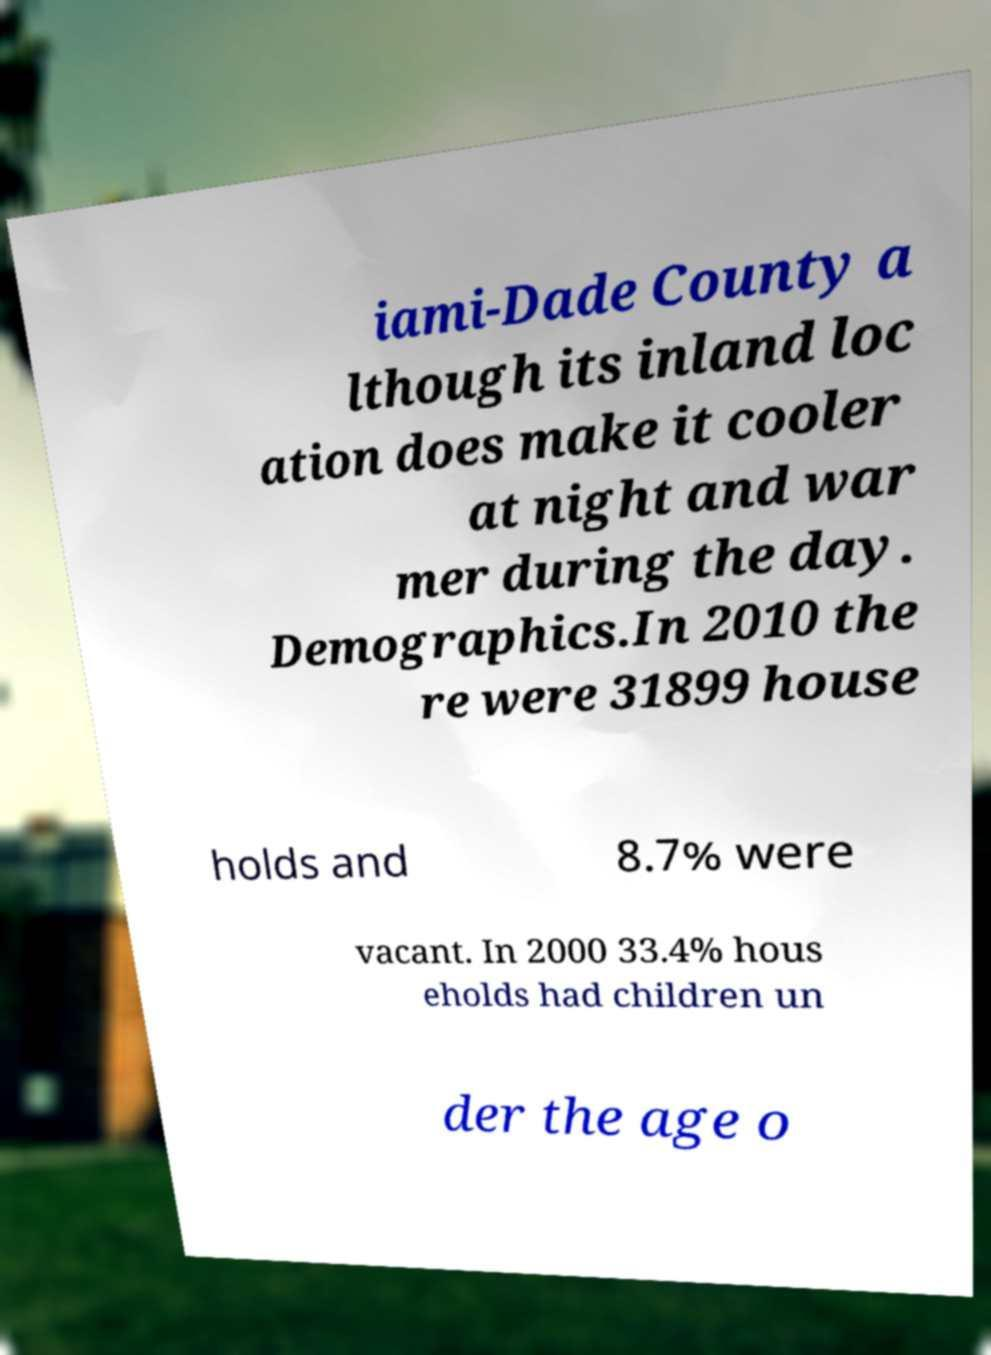Please read and relay the text visible in this image. What does it say? iami-Dade County a lthough its inland loc ation does make it cooler at night and war mer during the day. Demographics.In 2010 the re were 31899 house holds and 8.7% were vacant. In 2000 33.4% hous eholds had children un der the age o 